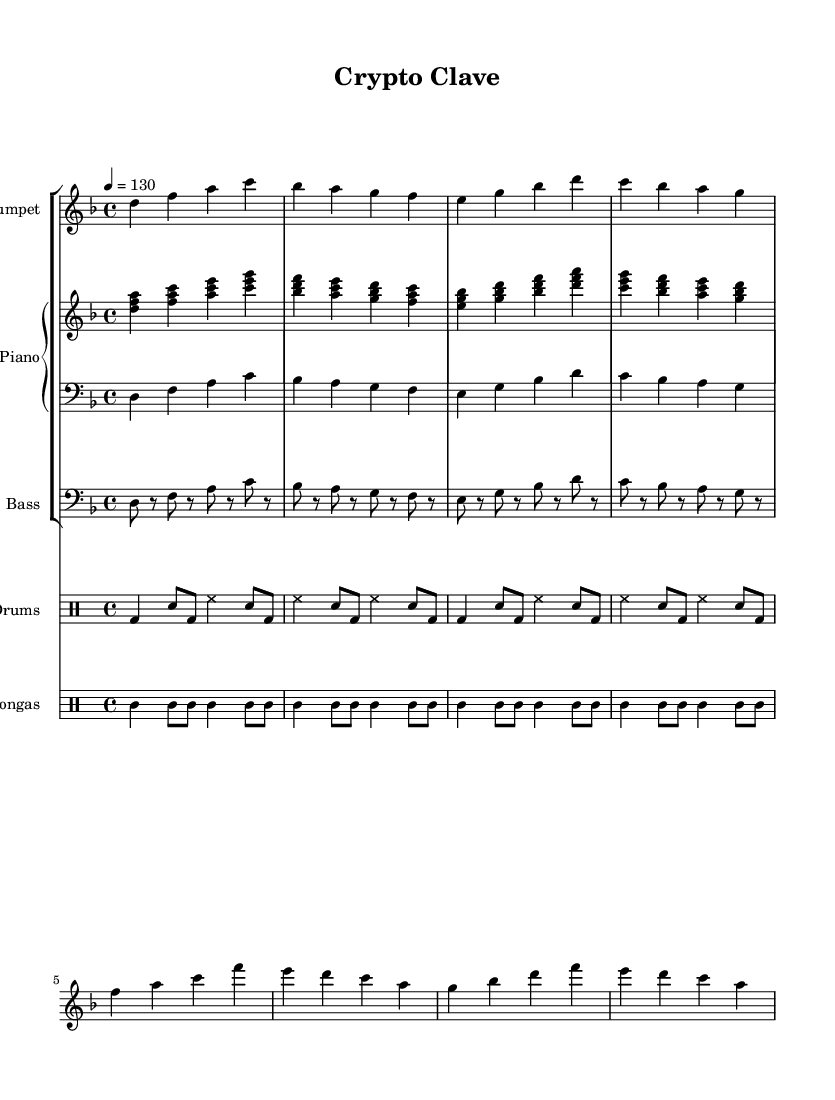What is the key signature of this music? The key signature is represented by the sharp and flat symbols at the beginning of the staff. In this case, there are no sharps or flats indicated, which means the key is D minor.
Answer: D minor What is the time signature of this piece? The time signature is indicated at the beginning of the score, showing two numbers stacked vertically. Here, the time signature 4/4 indicates that there are four beats per measure and the quarter note gets one beat.
Answer: 4/4 What is the tempo marking for this music? The tempo marking appears above the staff indicating the speed of the piece. The indication "4 = 130" means that there are 130 beats per minute.
Answer: 130 How many measures are there in the trumpet part? Counting the vertical bar lines dividing the music into measures helps determine the total number of measures in the trumpet part. The trumpet part shows 8 measures when counted.
Answer: 8 What is the rhythmic pattern for the congas in the first measure? The first measure of the congas shows "cgh4 cgl8," which indicates that the first note is a quarter note and is followed by an eighth note. The specific sounds in each part reference the conga rhythms typical in Latin music.
Answer: cgh4 cgl8 What type of musical elements are most prominent in Latin jazz fusion demonstrated here? In analyzing the rhythmic styles and improvisation commonly found in Latin jazz fusion, we notice that syncopated rhythms and call-and-response patterns between instruments represent these musical elements.
Answer: Syncopation What instrument plays the bass line in this composition? Upon examination of the score, the last group labeled indicates the instrument specifically notated for the bass line, which is the "Bass" part beneath the piano staff that corresponds to low pitches.
Answer: Bass 